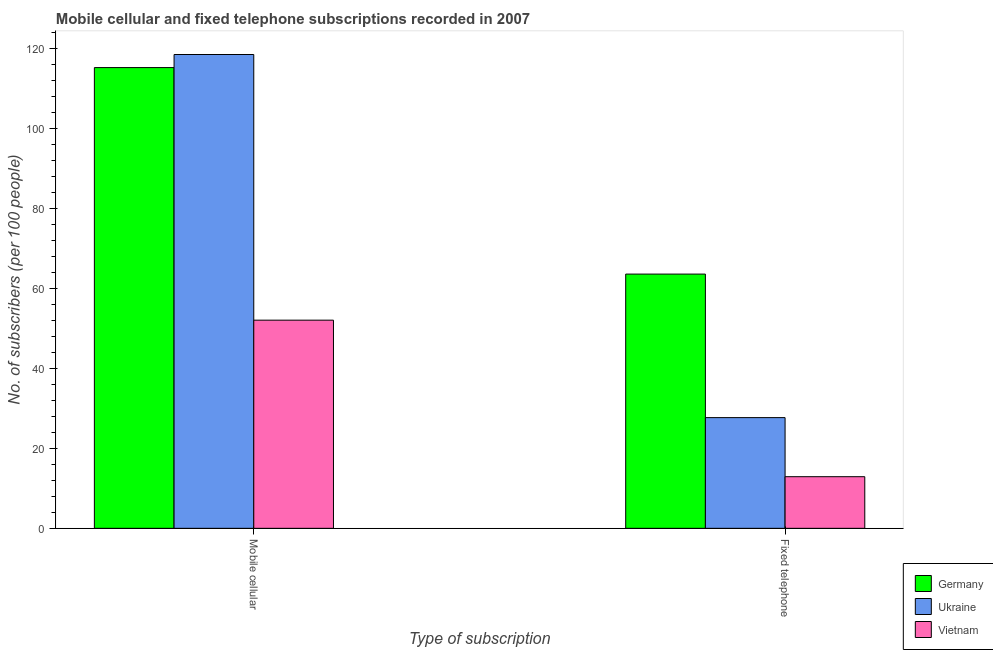How many groups of bars are there?
Offer a very short reply. 2. Are the number of bars on each tick of the X-axis equal?
Give a very brief answer. Yes. What is the label of the 2nd group of bars from the left?
Make the answer very short. Fixed telephone. What is the number of mobile cellular subscribers in Germany?
Provide a short and direct response. 115.14. Across all countries, what is the maximum number of fixed telephone subscribers?
Your answer should be compact. 63.53. Across all countries, what is the minimum number of mobile cellular subscribers?
Ensure brevity in your answer.  52.02. In which country was the number of mobile cellular subscribers maximum?
Keep it short and to the point. Ukraine. In which country was the number of fixed telephone subscribers minimum?
Ensure brevity in your answer.  Vietnam. What is the total number of fixed telephone subscribers in the graph?
Give a very brief answer. 104.1. What is the difference between the number of fixed telephone subscribers in Germany and that in Ukraine?
Your answer should be compact. 35.87. What is the difference between the number of mobile cellular subscribers in Ukraine and the number of fixed telephone subscribers in Germany?
Provide a succinct answer. 54.87. What is the average number of mobile cellular subscribers per country?
Give a very brief answer. 95.19. What is the difference between the number of mobile cellular subscribers and number of fixed telephone subscribers in Germany?
Offer a very short reply. 51.61. In how many countries, is the number of mobile cellular subscribers greater than 120 ?
Ensure brevity in your answer.  0. What is the ratio of the number of mobile cellular subscribers in Vietnam to that in Germany?
Your response must be concise. 0.45. What does the 2nd bar from the left in Fixed telephone represents?
Offer a very short reply. Ukraine. What does the 1st bar from the right in Fixed telephone represents?
Provide a short and direct response. Vietnam. How many bars are there?
Your response must be concise. 6. Are all the bars in the graph horizontal?
Offer a terse response. No. What is the difference between two consecutive major ticks on the Y-axis?
Your answer should be compact. 20. How are the legend labels stacked?
Keep it short and to the point. Vertical. What is the title of the graph?
Your answer should be compact. Mobile cellular and fixed telephone subscriptions recorded in 2007. Does "Cabo Verde" appear as one of the legend labels in the graph?
Make the answer very short. No. What is the label or title of the X-axis?
Offer a terse response. Type of subscription. What is the label or title of the Y-axis?
Give a very brief answer. No. of subscribers (per 100 people). What is the No. of subscribers (per 100 people) in Germany in Mobile cellular?
Your answer should be compact. 115.14. What is the No. of subscribers (per 100 people) of Ukraine in Mobile cellular?
Provide a short and direct response. 118.41. What is the No. of subscribers (per 100 people) of Vietnam in Mobile cellular?
Provide a succinct answer. 52.02. What is the No. of subscribers (per 100 people) of Germany in Fixed telephone?
Give a very brief answer. 63.53. What is the No. of subscribers (per 100 people) in Ukraine in Fixed telephone?
Offer a terse response. 27.66. What is the No. of subscribers (per 100 people) of Vietnam in Fixed telephone?
Keep it short and to the point. 12.9. Across all Type of subscription, what is the maximum No. of subscribers (per 100 people) of Germany?
Your response must be concise. 115.14. Across all Type of subscription, what is the maximum No. of subscribers (per 100 people) in Ukraine?
Offer a terse response. 118.41. Across all Type of subscription, what is the maximum No. of subscribers (per 100 people) of Vietnam?
Offer a terse response. 52.02. Across all Type of subscription, what is the minimum No. of subscribers (per 100 people) of Germany?
Your answer should be very brief. 63.53. Across all Type of subscription, what is the minimum No. of subscribers (per 100 people) in Ukraine?
Keep it short and to the point. 27.66. Across all Type of subscription, what is the minimum No. of subscribers (per 100 people) of Vietnam?
Make the answer very short. 12.9. What is the total No. of subscribers (per 100 people) in Germany in the graph?
Offer a very short reply. 178.67. What is the total No. of subscribers (per 100 people) in Ukraine in the graph?
Make the answer very short. 146.07. What is the total No. of subscribers (per 100 people) in Vietnam in the graph?
Your response must be concise. 64.92. What is the difference between the No. of subscribers (per 100 people) of Germany in Mobile cellular and that in Fixed telephone?
Provide a short and direct response. 51.61. What is the difference between the No. of subscribers (per 100 people) of Ukraine in Mobile cellular and that in Fixed telephone?
Your response must be concise. 90.74. What is the difference between the No. of subscribers (per 100 people) in Vietnam in Mobile cellular and that in Fixed telephone?
Make the answer very short. 39.12. What is the difference between the No. of subscribers (per 100 people) in Germany in Mobile cellular and the No. of subscribers (per 100 people) in Ukraine in Fixed telephone?
Provide a short and direct response. 87.48. What is the difference between the No. of subscribers (per 100 people) in Germany in Mobile cellular and the No. of subscribers (per 100 people) in Vietnam in Fixed telephone?
Provide a succinct answer. 102.24. What is the difference between the No. of subscribers (per 100 people) in Ukraine in Mobile cellular and the No. of subscribers (per 100 people) in Vietnam in Fixed telephone?
Provide a succinct answer. 105.51. What is the average No. of subscribers (per 100 people) of Germany per Type of subscription?
Keep it short and to the point. 89.34. What is the average No. of subscribers (per 100 people) in Ukraine per Type of subscription?
Offer a terse response. 73.03. What is the average No. of subscribers (per 100 people) in Vietnam per Type of subscription?
Provide a short and direct response. 32.46. What is the difference between the No. of subscribers (per 100 people) in Germany and No. of subscribers (per 100 people) in Ukraine in Mobile cellular?
Offer a very short reply. -3.27. What is the difference between the No. of subscribers (per 100 people) of Germany and No. of subscribers (per 100 people) of Vietnam in Mobile cellular?
Provide a short and direct response. 63.12. What is the difference between the No. of subscribers (per 100 people) in Ukraine and No. of subscribers (per 100 people) in Vietnam in Mobile cellular?
Make the answer very short. 66.39. What is the difference between the No. of subscribers (per 100 people) in Germany and No. of subscribers (per 100 people) in Ukraine in Fixed telephone?
Your response must be concise. 35.87. What is the difference between the No. of subscribers (per 100 people) in Germany and No. of subscribers (per 100 people) in Vietnam in Fixed telephone?
Your answer should be compact. 50.63. What is the difference between the No. of subscribers (per 100 people) in Ukraine and No. of subscribers (per 100 people) in Vietnam in Fixed telephone?
Provide a short and direct response. 14.76. What is the ratio of the No. of subscribers (per 100 people) in Germany in Mobile cellular to that in Fixed telephone?
Offer a terse response. 1.81. What is the ratio of the No. of subscribers (per 100 people) of Ukraine in Mobile cellular to that in Fixed telephone?
Give a very brief answer. 4.28. What is the ratio of the No. of subscribers (per 100 people) of Vietnam in Mobile cellular to that in Fixed telephone?
Your response must be concise. 4.03. What is the difference between the highest and the second highest No. of subscribers (per 100 people) of Germany?
Your answer should be compact. 51.61. What is the difference between the highest and the second highest No. of subscribers (per 100 people) of Ukraine?
Give a very brief answer. 90.74. What is the difference between the highest and the second highest No. of subscribers (per 100 people) in Vietnam?
Keep it short and to the point. 39.12. What is the difference between the highest and the lowest No. of subscribers (per 100 people) in Germany?
Offer a very short reply. 51.61. What is the difference between the highest and the lowest No. of subscribers (per 100 people) of Ukraine?
Make the answer very short. 90.74. What is the difference between the highest and the lowest No. of subscribers (per 100 people) of Vietnam?
Make the answer very short. 39.12. 